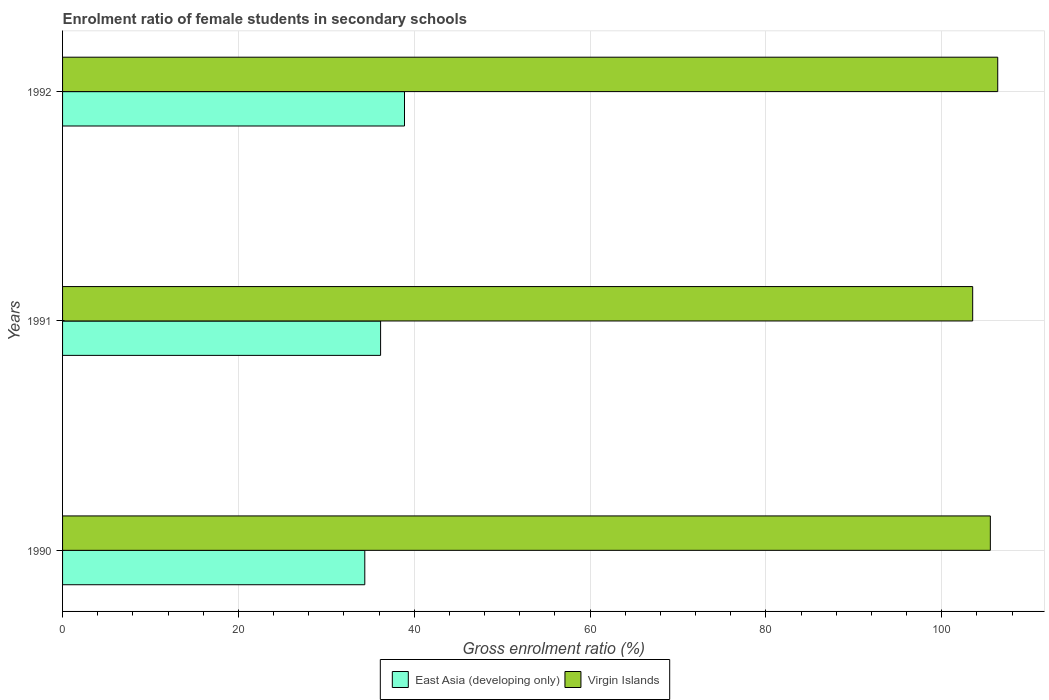How many different coloured bars are there?
Ensure brevity in your answer.  2. Are the number of bars per tick equal to the number of legend labels?
Offer a very short reply. Yes. How many bars are there on the 1st tick from the top?
Your answer should be compact. 2. In how many cases, is the number of bars for a given year not equal to the number of legend labels?
Provide a short and direct response. 0. What is the enrolment ratio of female students in secondary schools in Virgin Islands in 1991?
Your answer should be very brief. 103.52. Across all years, what is the maximum enrolment ratio of female students in secondary schools in East Asia (developing only)?
Your response must be concise. 38.89. Across all years, what is the minimum enrolment ratio of female students in secondary schools in Virgin Islands?
Offer a terse response. 103.52. In which year was the enrolment ratio of female students in secondary schools in Virgin Islands maximum?
Ensure brevity in your answer.  1992. In which year was the enrolment ratio of female students in secondary schools in Virgin Islands minimum?
Provide a succinct answer. 1991. What is the total enrolment ratio of female students in secondary schools in Virgin Islands in the graph?
Ensure brevity in your answer.  315.4. What is the difference between the enrolment ratio of female students in secondary schools in Virgin Islands in 1991 and that in 1992?
Make the answer very short. -2.85. What is the difference between the enrolment ratio of female students in secondary schools in Virgin Islands in 1990 and the enrolment ratio of female students in secondary schools in East Asia (developing only) in 1992?
Your response must be concise. 66.63. What is the average enrolment ratio of female students in secondary schools in Virgin Islands per year?
Ensure brevity in your answer.  105.13. In the year 1991, what is the difference between the enrolment ratio of female students in secondary schools in East Asia (developing only) and enrolment ratio of female students in secondary schools in Virgin Islands?
Keep it short and to the point. -67.34. What is the ratio of the enrolment ratio of female students in secondary schools in East Asia (developing only) in 1990 to that in 1992?
Your answer should be compact. 0.88. Is the enrolment ratio of female students in secondary schools in Virgin Islands in 1991 less than that in 1992?
Provide a short and direct response. Yes. What is the difference between the highest and the second highest enrolment ratio of female students in secondary schools in East Asia (developing only)?
Give a very brief answer. 2.72. What is the difference between the highest and the lowest enrolment ratio of female students in secondary schools in Virgin Islands?
Make the answer very short. 2.85. In how many years, is the enrolment ratio of female students in secondary schools in East Asia (developing only) greater than the average enrolment ratio of female students in secondary schools in East Asia (developing only) taken over all years?
Your answer should be very brief. 1. What does the 2nd bar from the top in 1991 represents?
Your answer should be very brief. East Asia (developing only). What does the 2nd bar from the bottom in 1991 represents?
Provide a succinct answer. Virgin Islands. Are all the bars in the graph horizontal?
Your response must be concise. Yes. How many years are there in the graph?
Provide a short and direct response. 3. Does the graph contain grids?
Give a very brief answer. Yes. How are the legend labels stacked?
Offer a terse response. Horizontal. What is the title of the graph?
Ensure brevity in your answer.  Enrolment ratio of female students in secondary schools. What is the label or title of the X-axis?
Your answer should be very brief. Gross enrolment ratio (%). What is the label or title of the Y-axis?
Keep it short and to the point. Years. What is the Gross enrolment ratio (%) in East Asia (developing only) in 1990?
Your answer should be compact. 34.37. What is the Gross enrolment ratio (%) of Virgin Islands in 1990?
Offer a very short reply. 105.52. What is the Gross enrolment ratio (%) of East Asia (developing only) in 1991?
Your answer should be very brief. 36.17. What is the Gross enrolment ratio (%) in Virgin Islands in 1991?
Offer a terse response. 103.52. What is the Gross enrolment ratio (%) in East Asia (developing only) in 1992?
Give a very brief answer. 38.89. What is the Gross enrolment ratio (%) in Virgin Islands in 1992?
Keep it short and to the point. 106.36. Across all years, what is the maximum Gross enrolment ratio (%) of East Asia (developing only)?
Provide a short and direct response. 38.89. Across all years, what is the maximum Gross enrolment ratio (%) in Virgin Islands?
Your answer should be compact. 106.36. Across all years, what is the minimum Gross enrolment ratio (%) of East Asia (developing only)?
Your answer should be compact. 34.37. Across all years, what is the minimum Gross enrolment ratio (%) in Virgin Islands?
Offer a terse response. 103.52. What is the total Gross enrolment ratio (%) of East Asia (developing only) in the graph?
Make the answer very short. 109.44. What is the total Gross enrolment ratio (%) in Virgin Islands in the graph?
Provide a succinct answer. 315.4. What is the difference between the Gross enrolment ratio (%) in East Asia (developing only) in 1990 and that in 1991?
Offer a very short reply. -1.8. What is the difference between the Gross enrolment ratio (%) of Virgin Islands in 1990 and that in 1991?
Offer a terse response. 2.01. What is the difference between the Gross enrolment ratio (%) of East Asia (developing only) in 1990 and that in 1992?
Provide a succinct answer. -4.52. What is the difference between the Gross enrolment ratio (%) in Virgin Islands in 1990 and that in 1992?
Provide a short and direct response. -0.84. What is the difference between the Gross enrolment ratio (%) in East Asia (developing only) in 1991 and that in 1992?
Ensure brevity in your answer.  -2.72. What is the difference between the Gross enrolment ratio (%) of Virgin Islands in 1991 and that in 1992?
Provide a succinct answer. -2.85. What is the difference between the Gross enrolment ratio (%) of East Asia (developing only) in 1990 and the Gross enrolment ratio (%) of Virgin Islands in 1991?
Offer a very short reply. -69.14. What is the difference between the Gross enrolment ratio (%) of East Asia (developing only) in 1990 and the Gross enrolment ratio (%) of Virgin Islands in 1992?
Provide a short and direct response. -71.99. What is the difference between the Gross enrolment ratio (%) in East Asia (developing only) in 1991 and the Gross enrolment ratio (%) in Virgin Islands in 1992?
Give a very brief answer. -70.19. What is the average Gross enrolment ratio (%) of East Asia (developing only) per year?
Make the answer very short. 36.48. What is the average Gross enrolment ratio (%) in Virgin Islands per year?
Keep it short and to the point. 105.13. In the year 1990, what is the difference between the Gross enrolment ratio (%) in East Asia (developing only) and Gross enrolment ratio (%) in Virgin Islands?
Make the answer very short. -71.15. In the year 1991, what is the difference between the Gross enrolment ratio (%) in East Asia (developing only) and Gross enrolment ratio (%) in Virgin Islands?
Your response must be concise. -67.34. In the year 1992, what is the difference between the Gross enrolment ratio (%) in East Asia (developing only) and Gross enrolment ratio (%) in Virgin Islands?
Keep it short and to the point. -67.47. What is the ratio of the Gross enrolment ratio (%) in East Asia (developing only) in 1990 to that in 1991?
Keep it short and to the point. 0.95. What is the ratio of the Gross enrolment ratio (%) in Virgin Islands in 1990 to that in 1991?
Provide a short and direct response. 1.02. What is the ratio of the Gross enrolment ratio (%) of East Asia (developing only) in 1990 to that in 1992?
Offer a terse response. 0.88. What is the ratio of the Gross enrolment ratio (%) in Virgin Islands in 1990 to that in 1992?
Make the answer very short. 0.99. What is the ratio of the Gross enrolment ratio (%) of East Asia (developing only) in 1991 to that in 1992?
Give a very brief answer. 0.93. What is the ratio of the Gross enrolment ratio (%) in Virgin Islands in 1991 to that in 1992?
Keep it short and to the point. 0.97. What is the difference between the highest and the second highest Gross enrolment ratio (%) in East Asia (developing only)?
Your answer should be compact. 2.72. What is the difference between the highest and the second highest Gross enrolment ratio (%) of Virgin Islands?
Give a very brief answer. 0.84. What is the difference between the highest and the lowest Gross enrolment ratio (%) in East Asia (developing only)?
Ensure brevity in your answer.  4.52. What is the difference between the highest and the lowest Gross enrolment ratio (%) in Virgin Islands?
Your answer should be compact. 2.85. 